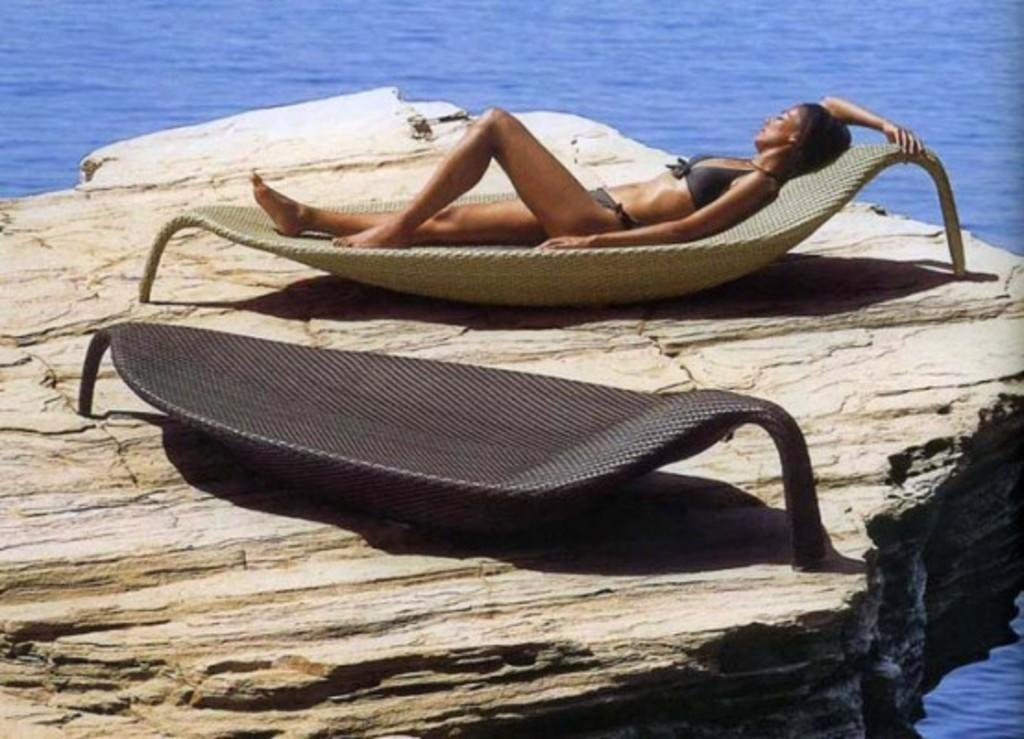Who is present in the image? There is a woman in the image. What is the woman doing in the image? The woman is on a beach bed. Where is the beach bed located? The beach bed is on a rock. What can be seen in the background of the image? There is water visible in the image. How many boys are playing with the horses in the image? There are no boys or horses present in the image. 